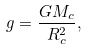Convert formula to latex. <formula><loc_0><loc_0><loc_500><loc_500>g = \frac { G M _ { c } } { R _ { c } ^ { 2 } } ,</formula> 